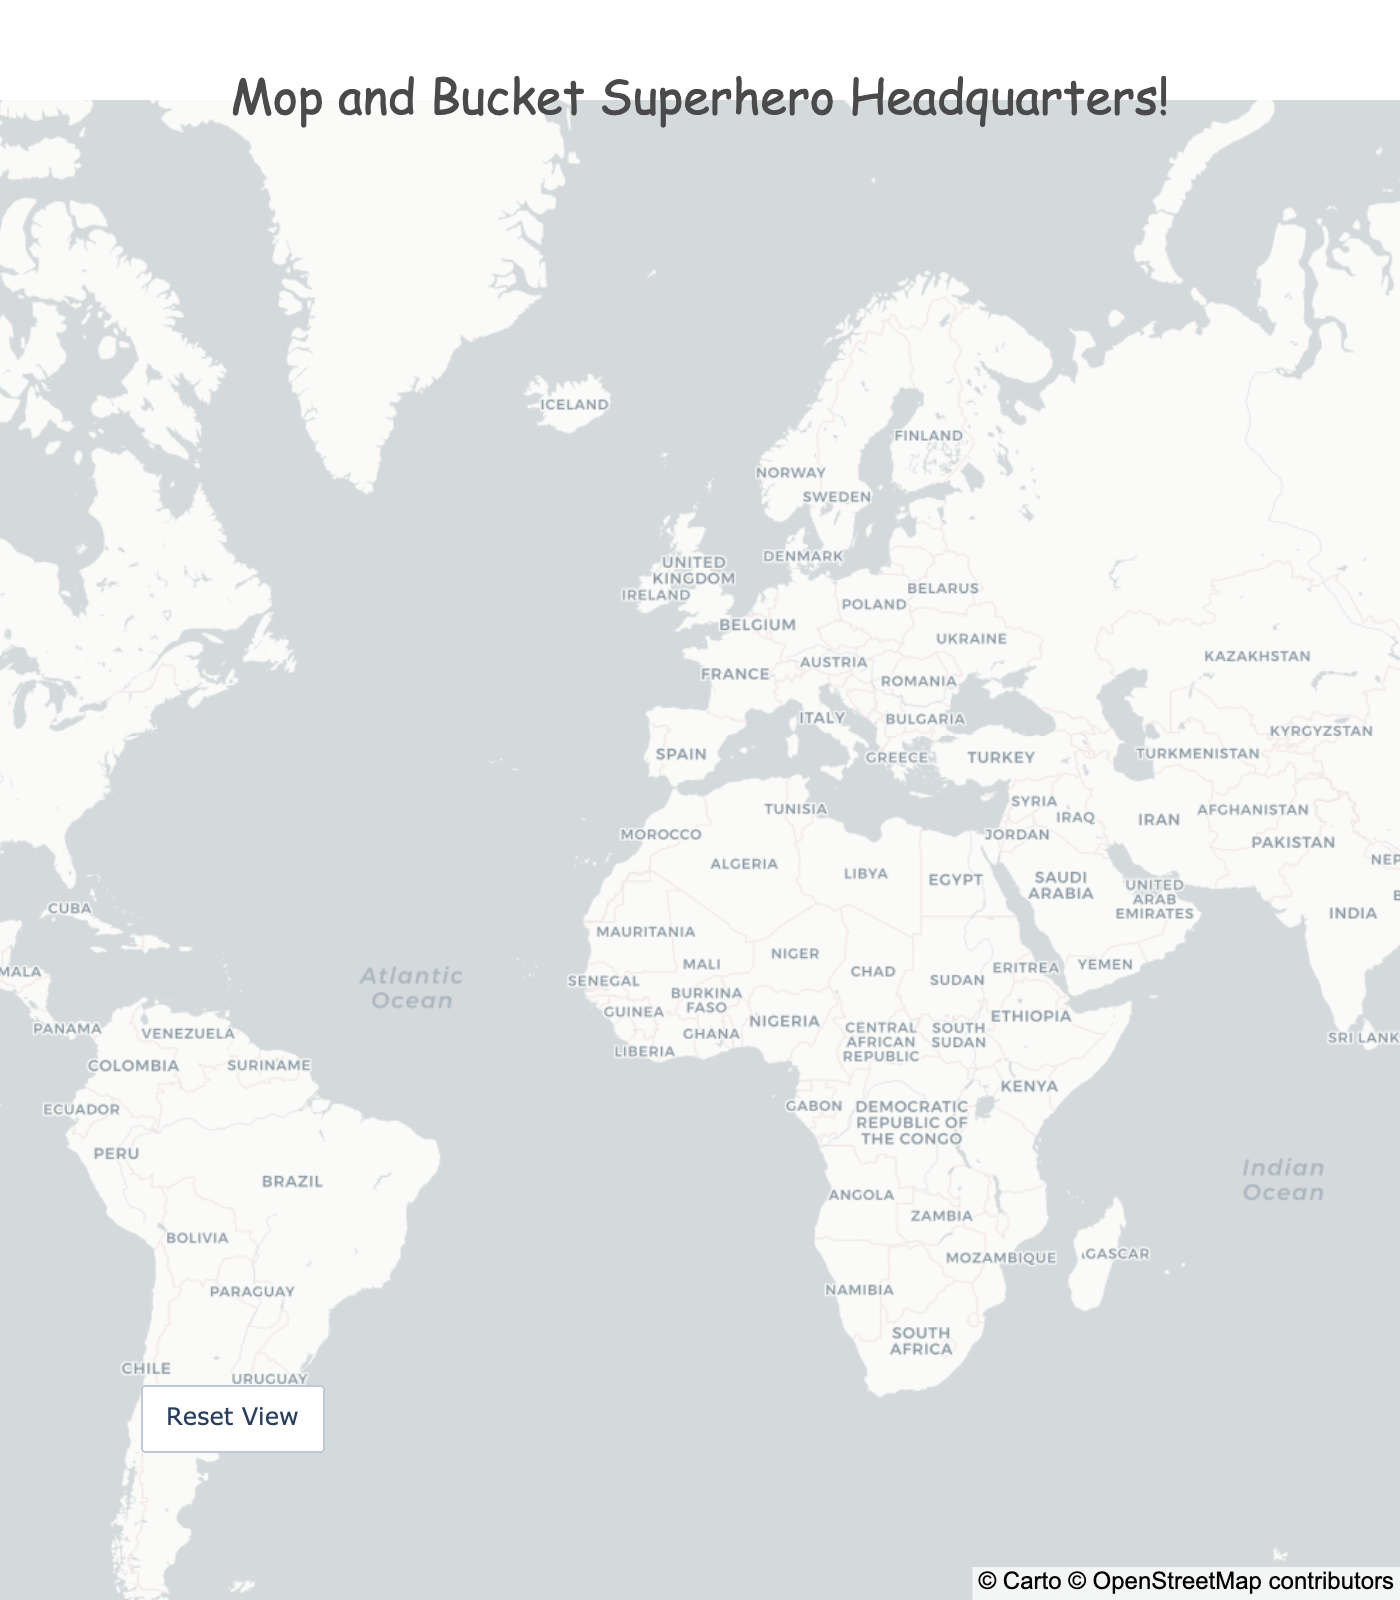Where is the headquarters of Rubbermaid Commercial Products? Look at the figure and find the star labeled "Rubbermaid Commercial Products." The hover information will show the city and country.
Answer: Winchester, USA Which country has the most mop and bucket manufacturer headquarters on the map? Count the number of stars in each country as indicated in their hover information. Germany has two manufacturers: Vileda and Unger Global.
Answer: Germany What is the title of the map? The title is displayed at the top center of the map.
Answer: Mop and Bucket Superhero Headquarters! How many mop and bucket manufacturer headquarters are located in Europe? Identify and count the stars located in European countries: Vileda in Germany, Unger Global in Germany, Cleanfix in Switzerland, and Spontex in France.
Answer: 4 Which manufacturer is located farthest south? Look at the latitude values and find the smallest (most negative) number, which represents the farthest south location. Oates in Melbourne, Australia has a latitude of -37.8136.
Answer: Oates Between Vileda and 3M, which one is located farther west? Compare the longitude values for Vileda in Germany (8.6602) and 3M in St. Paul, USA (-93.0900). A smaller (more negative) longitude means farther west.
Answer: 3M Which company is headquartered in Paris' suburb area? Find the manufacturer near Paris by referring to the hover information for each star. Spontex is located in Colombes, which is a suburb of Paris.
Answer: Spontex How many headquarters can be found in the southern hemisphere? Locate stars in the southern hemisphere by identifying negative latitude values for manufacturers located in Australia: Oates and Sabco.
Answer: 2 Are there more manufacturers in the USA or Australia? Count the stars in the USA (3: Rubbermaid Commercial Products, O-Cedar, 3M) and Australia (2: Oates, Sabco).
Answer: USA Which company has the highest latitude? Look for the largest positive latitude value from the hover information. Unger Global in Solingen, Germany has the highest latitude at 51.1710.
Answer: Unger Global 